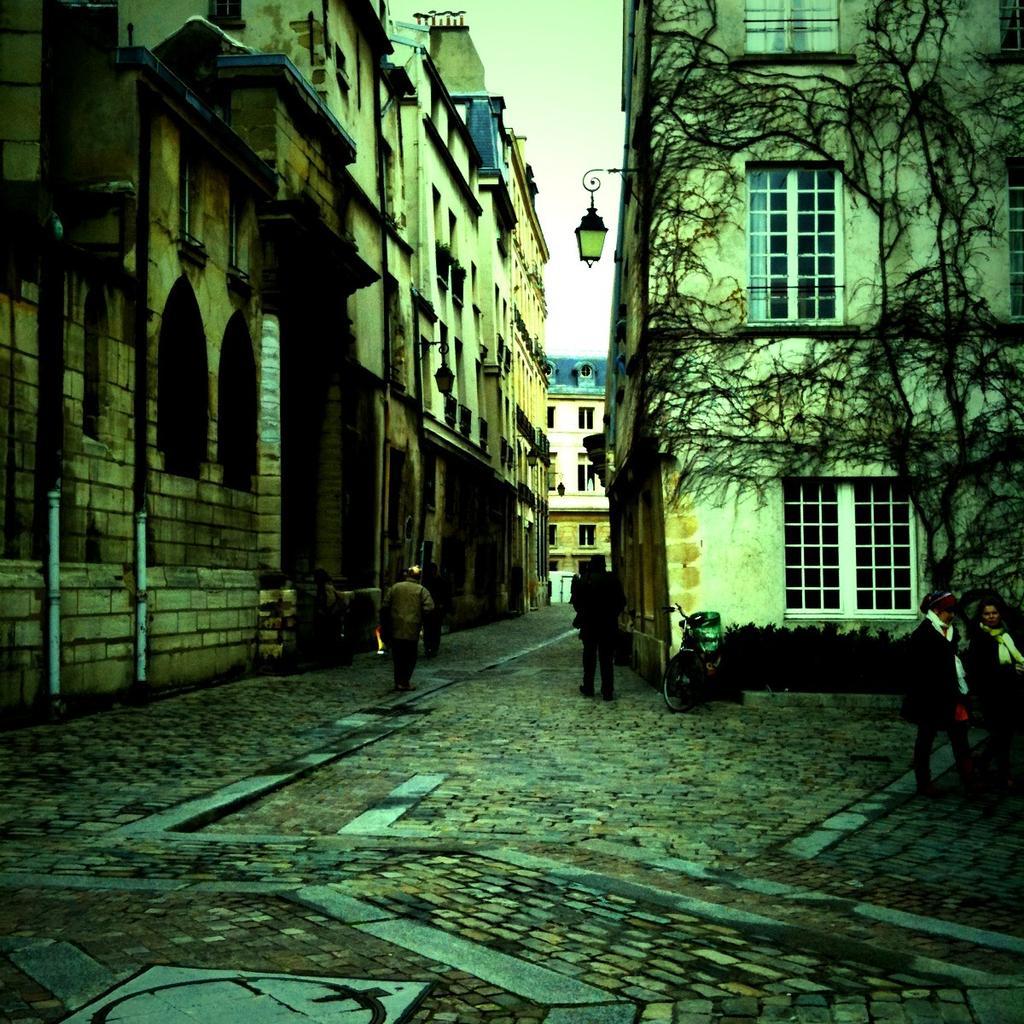Can you describe this image briefly? In this image there are a few people walking on the streets. On the streets there is a cycle, trash can and plants. In the background of the image there are buildings with glass windows and lamps. 